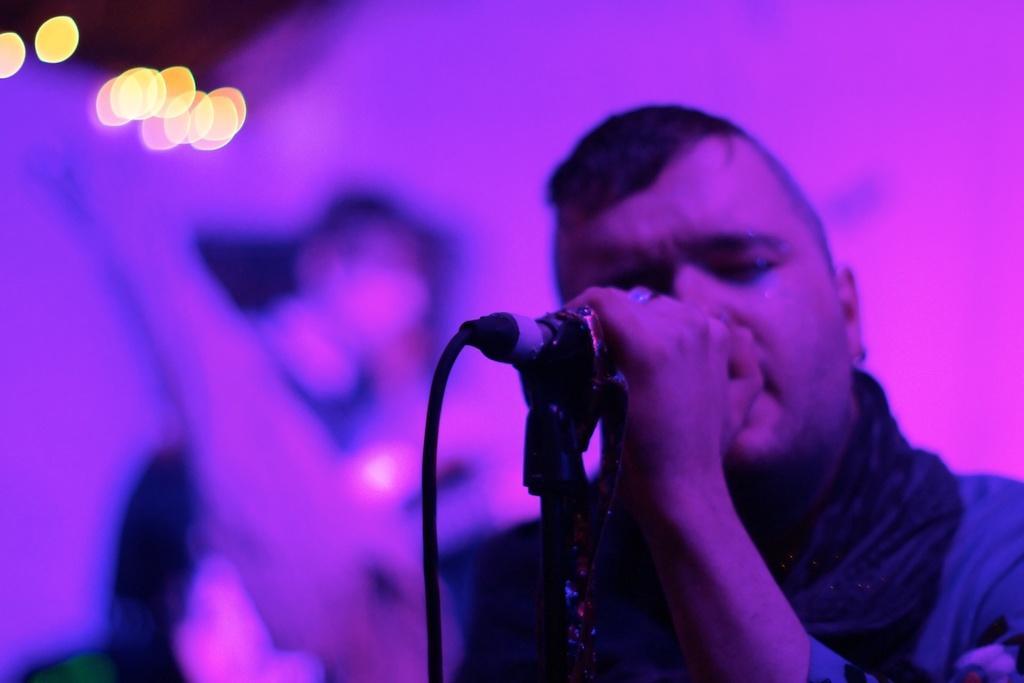How would you summarize this image in a sentence or two? This picture describes about few people, on the left side of the image we can see a man, he is holding a microphone, in the background we can see few lights. 